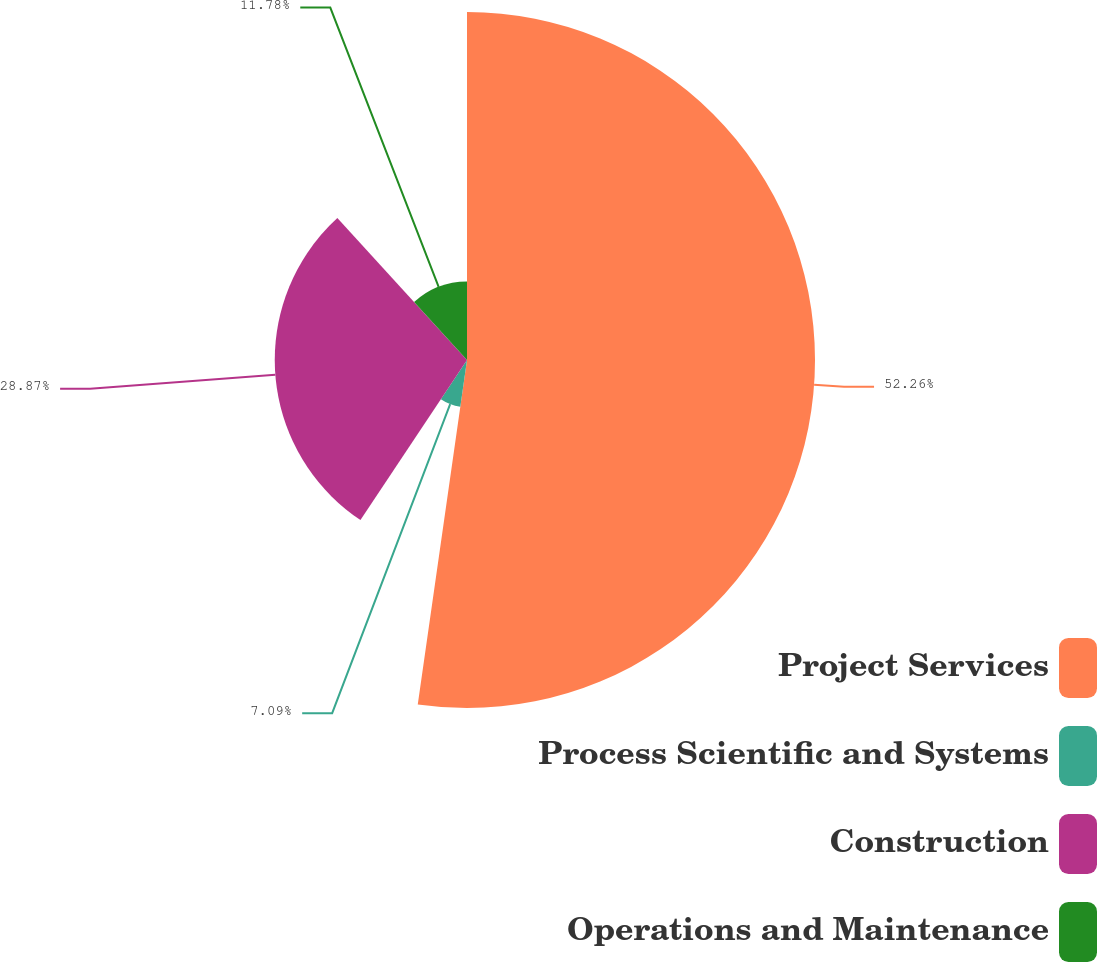<chart> <loc_0><loc_0><loc_500><loc_500><pie_chart><fcel>Project Services<fcel>Process Scientific and Systems<fcel>Construction<fcel>Operations and Maintenance<nl><fcel>52.26%<fcel>7.09%<fcel>28.87%<fcel>11.78%<nl></chart> 